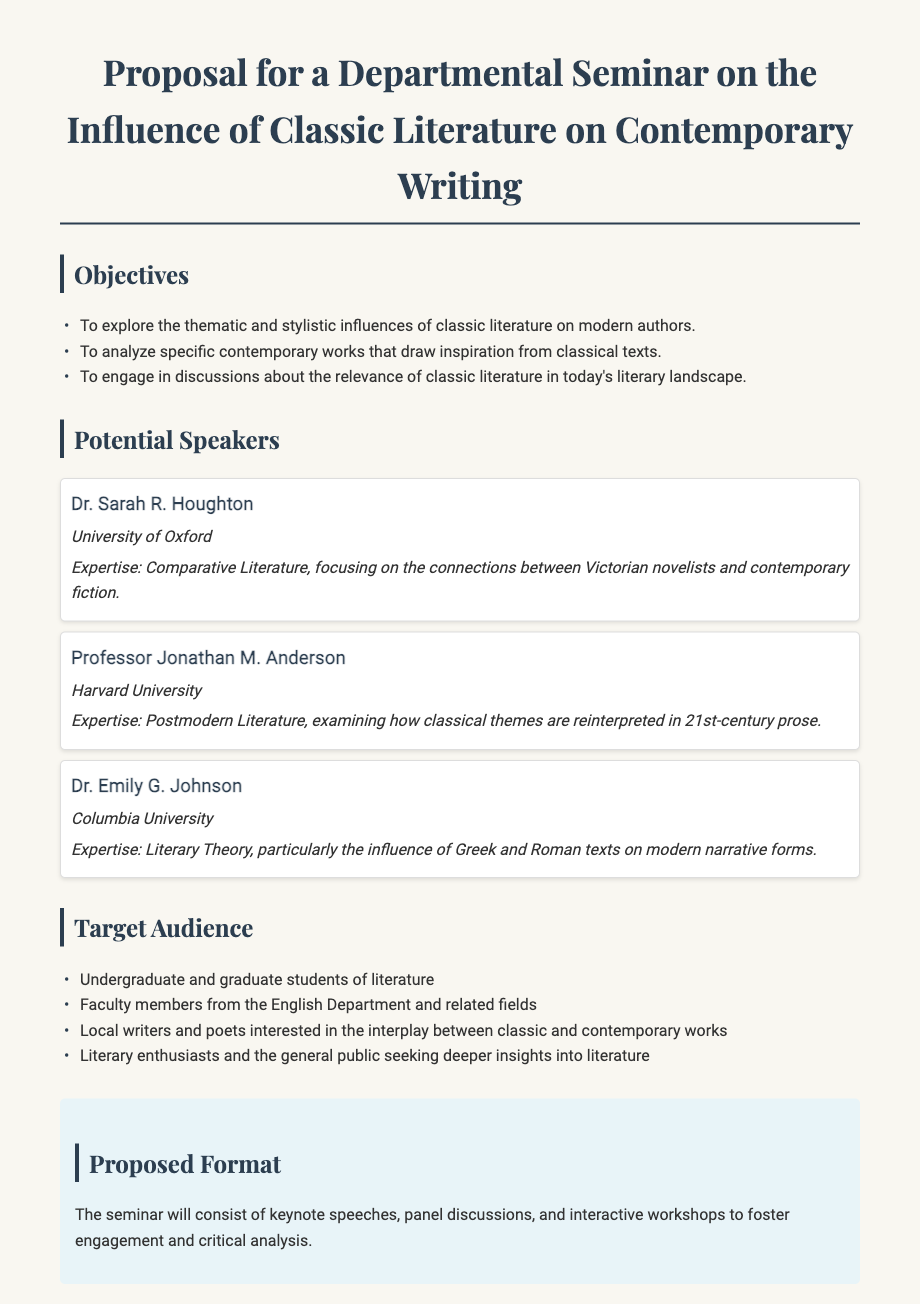What is the title of the seminar proposal? The title is stated at the top of the document, clearly indicating the subject of the seminar.
Answer: Proposal for a Departmental Seminar on the Influence of Classic Literature on Contemporary Writing Who is one of the potential speakers mentioned in the document? The document lists specific speakers under the "Potential Speakers" section.
Answer: Dr. Sarah R. Houghton What is one objective of the seminar? The objectives are listed in the "Objectives" section, detailing the aims of the seminar.
Answer: To explore the thematic and stylistic influences of classic literature on modern authors How many speakers are mentioned in total? The document provides a list of individual speakers, and counting them provides the total number.
Answer: Three What type of event format is proposed for the seminar? The document outlines the structure of the seminar in a dedicated section named "Proposed Format."
Answer: Keynote speeches, panel discussions, and interactive workshops Which audience is explicitly targeted in the proposal? The document specifies the target audience in the section titled "Target Audience."
Answer: Undergraduate and graduate students of literature What is the expertise of Professor Jonathan M. Anderson? The document describes the expertise of the speakers, revealing their areas of specialization.
Answer: Postmodern Literature What is one aspect of the proposal that emphasizes engagement? The "Proposed Format" section specifies the methods intended for engagement and analysis during the seminar.
Answer: Interactive workshops 